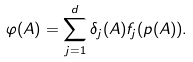Convert formula to latex. <formula><loc_0><loc_0><loc_500><loc_500>\varphi ( A ) = \sum _ { j = 1 } ^ { d } \delta _ { j } ( A ) f _ { j } ( p ( A ) ) .</formula> 